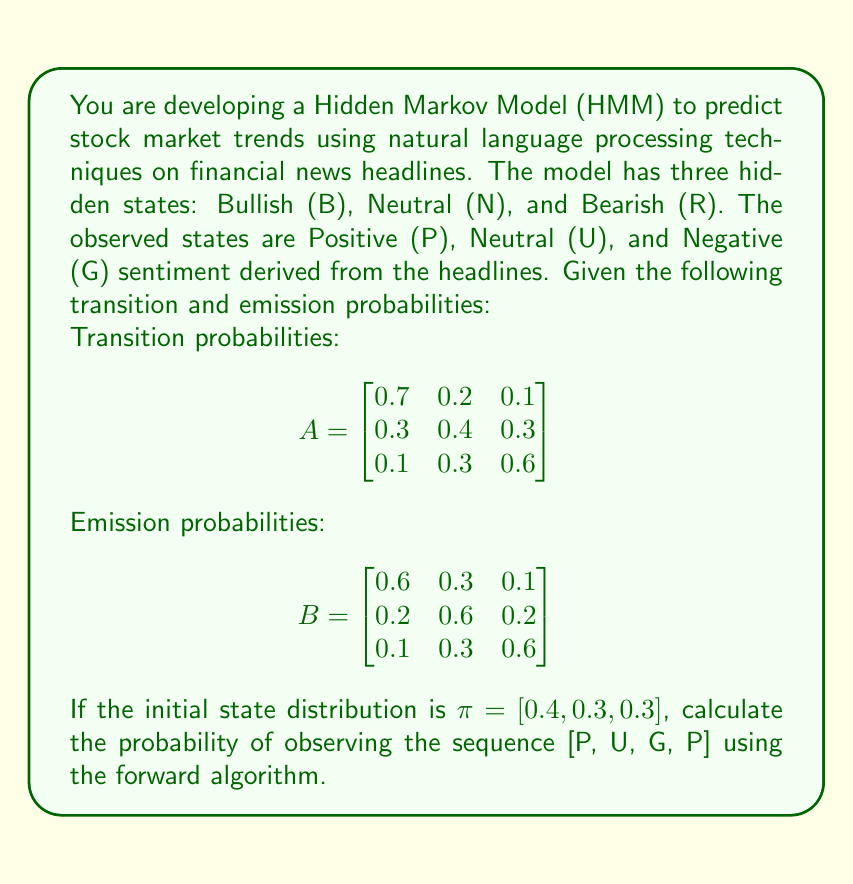Could you help me with this problem? To solve this problem, we'll use the forward algorithm, which is commonly used in Hidden Markov Models. The forward algorithm calculates the probability of an observation sequence given the model parameters. Let's break it down step by step:

1. Initialize the forward probabilities:
   $$\alpha_1(i) = \pi_i b_i(O_1)$$
   where $\pi_i$ is the initial probability of state $i$, and $b_i(O_1)$ is the emission probability of the first observation in state $i$.

2. Recursively calculate the forward probabilities:
   $$\alpha_t(j) = \sum_{i=1}^N \alpha_{t-1}(i) a_{ij} b_j(O_t)$$
   where $a_{ij}$ is the transition probability from state $i$ to state $j$, and $b_j(O_t)$ is the emission probability of observation $O_t$ in state $j$.

3. Sum the final forward probabilities to get the total probability of the sequence.

Let's apply these steps to our problem:

Step 1: Initialize forward probabilities
$$\alpha_1(B) = 0.4 \times 0.6 = 0.24$$
$$\alpha_1(N) = 0.3 \times 0.2 = 0.06$$
$$\alpha_1(R) = 0.3 \times 0.1 = 0.03$$

Step 2: Recursively calculate forward probabilities

For t = 2 (U):
$$\alpha_2(B) = (0.24 \times 0.7 + 0.06 \times 0.3 + 0.03 \times 0.1) \times 0.3 = 0.0549$$
$$\alpha_2(N) = (0.24 \times 0.2 + 0.06 \times 0.4 + 0.03 \times 0.3) \times 0.6 = 0.0456$$
$$\alpha_2(R) = (0.24 \times 0.1 + 0.06 \times 0.3 + 0.03 \times 0.6) \times 0.3 = 0.0117$$

For t = 3 (G):
$$\alpha_3(B) = (0.0549 \times 0.7 + 0.0456 \times 0.3 + 0.0117 \times 0.1) \times 0.1 = 0.00468$$
$$\alpha_3(N) = (0.0549 \times 0.2 + 0.0456 \times 0.4 + 0.0117 \times 0.3) \times 0.2 = 0.00280$$
$$\alpha_3(R) = (0.0549 \times 0.1 + 0.0456 \times 0.3 + 0.0117 \times 0.6) \times 0.6 = 0.00612$$

For t = 4 (P):
$$\alpha_4(B) = (0.00468 \times 0.7 + 0.00280 \times 0.3 + 0.00612 \times 0.1) \times 0.6 = 0.00252$$
$$\alpha_4(N) = (0.00468 \times 0.2 + 0.00280 \times 0.4 + 0.00612 \times 0.3) \times 0.2 = 0.00036$$
$$\alpha_4(R) = (0.00468 \times 0.1 + 0.00280 \times 0.3 + 0.00612 \times 0.6) \times 0.1 = 0.00005$$

Step 3: Sum the final forward probabilities
$$P(O|λ) = \alpha_4(B) + \alpha_4(N) + \alpha_4(R) = 0.00252 + 0.00036 + 0.00005 = 0.00293$$
Answer: The probability of observing the sequence [P, U, G, P] given the HMM parameters is approximately 0.00293 or 2.93 × 10^-3. 